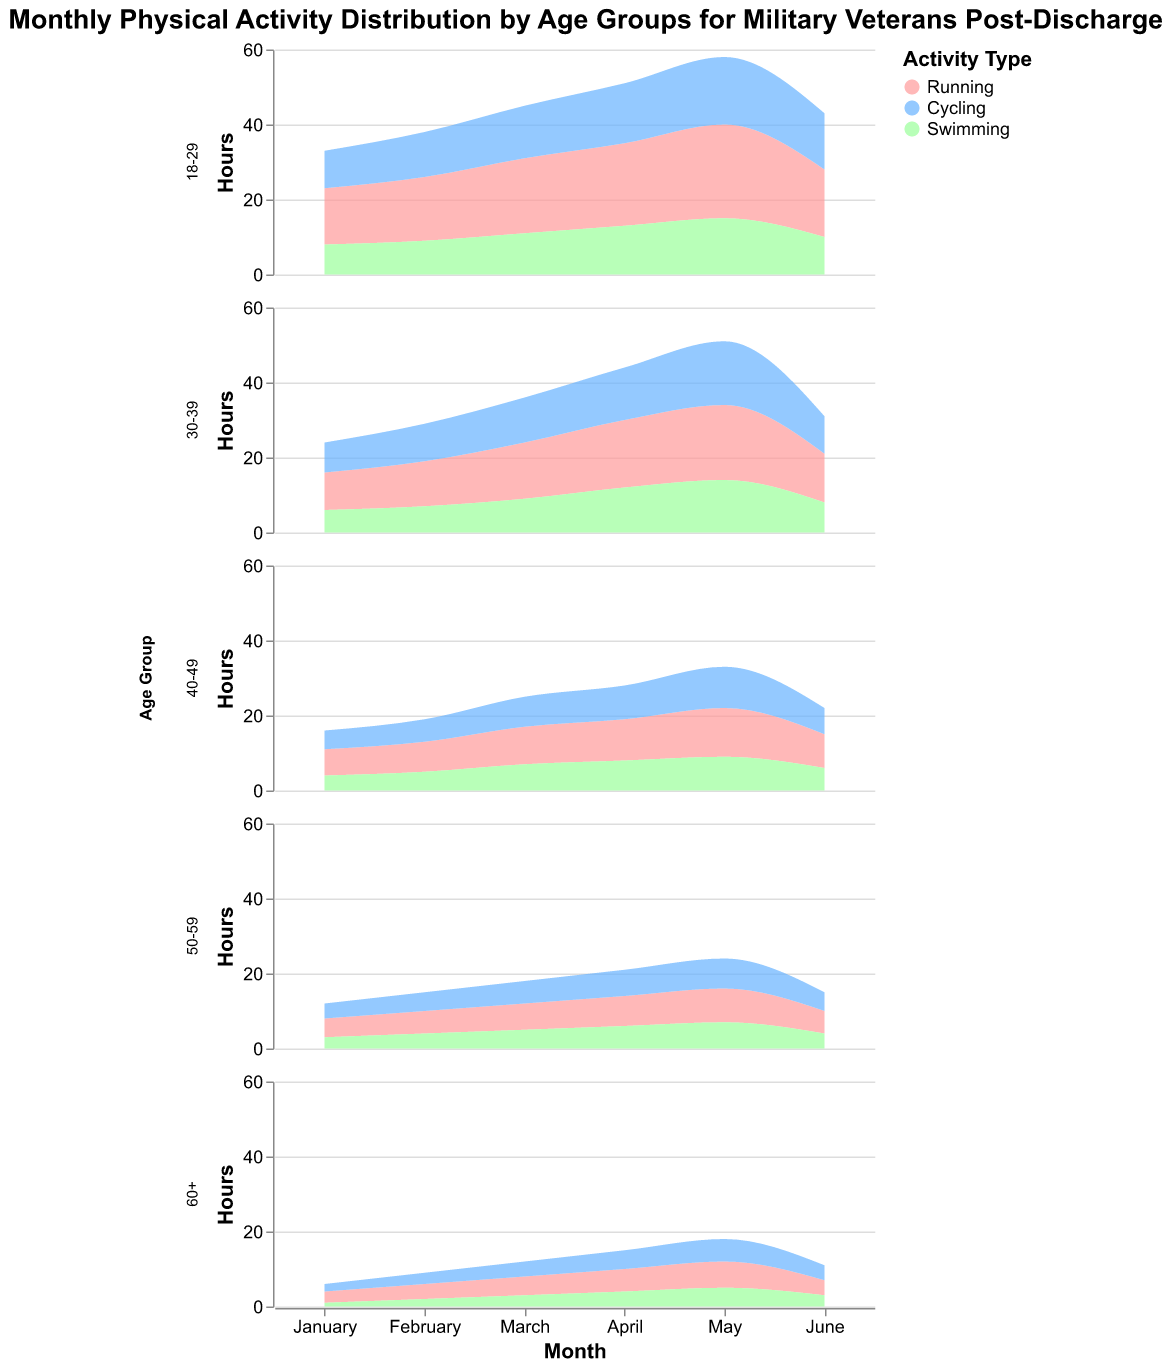What's the title of the figure? The title is the text at the top of the figure which provides a general overview of what the figure represents.
Answer: Monthly Physical Activity Distribution by Age Groups for Military Veterans Post-Discharge How many different age groups are represented in the figure? The figure uses multiple subplots to represent different age groups. By counting the number of subplots, we can determine the number of age groups.
Answer: 5 Which activity type is represented by the color green? The color green in the area chart represents one of the activity types. The legend in the figure shows that green corresponds to Swimming.
Answer: Swimming In the 18-29 age group, which month has the highest hours spent on running? By examining the 18-29 age group subplot and looking at the area for Running, we see that May has the highest running hours.
Answer: May What's the total number of hours spent on cycling in the 30-39 age group in May? By examining the 30-39 age group subplot, we find the value for cycling in May, which is 17 hours.
Answer: 17 Compare the running hours in June for the age groups 40-49 and 50-59. Which age group runs more in June? To compare, look at the June values for running in both the 40-49 and 50-59 subplots. The 40-49 age group has 9 hours, while the 50-59 age group has 6 hours.
Answer: 40-49 Which activity type has the drastic decrease from May to June in the 18-29 age group? By examining the 18-29 subplot for all activities from May to June, Running shows a noticeable decrease from 25 to 18 hours.
Answer: Running What is the sum of swimming hours for the 60+ age group across all months? Add the swimming hours across all months for the 60+ subplot: 1 (Jan) + 2 (Feb) + 3 (Mar) + 4 (Apr) + 5 (May) + 3 (Jun) = 18.
Answer: 18 How does the cycling activity for the 30-39 age group in January compare to February? By comparing the hours, cycling in January (8) is lower than cycling in February (10).
Answer: Lower in January What's the average number of hours spent running by the 50-59 age group over the six months? Sum the hours spent running (5+6+7+8+9+6) = 41 and divide by 6 months to get the average: 41/6 ≈ 6.83.
Answer: 6.83 